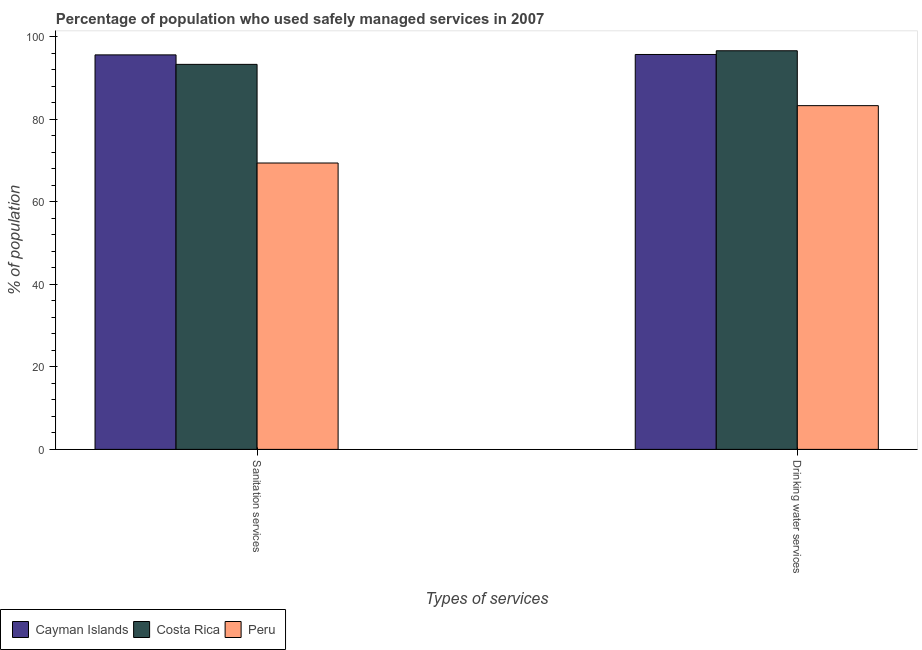Are the number of bars on each tick of the X-axis equal?
Provide a short and direct response. Yes. How many bars are there on the 2nd tick from the right?
Offer a very short reply. 3. What is the label of the 2nd group of bars from the left?
Offer a very short reply. Drinking water services. What is the percentage of population who used drinking water services in Costa Rica?
Provide a short and direct response. 96.6. Across all countries, what is the maximum percentage of population who used sanitation services?
Your response must be concise. 95.6. Across all countries, what is the minimum percentage of population who used sanitation services?
Offer a terse response. 69.4. In which country was the percentage of population who used sanitation services maximum?
Make the answer very short. Cayman Islands. In which country was the percentage of population who used drinking water services minimum?
Your answer should be very brief. Peru. What is the total percentage of population who used sanitation services in the graph?
Your answer should be very brief. 258.3. What is the difference between the percentage of population who used sanitation services in Costa Rica and that in Cayman Islands?
Provide a short and direct response. -2.3. What is the difference between the percentage of population who used drinking water services in Costa Rica and the percentage of population who used sanitation services in Cayman Islands?
Offer a very short reply. 1. What is the average percentage of population who used drinking water services per country?
Provide a short and direct response. 91.87. What is the difference between the percentage of population who used drinking water services and percentage of population who used sanitation services in Costa Rica?
Offer a very short reply. 3.3. In how many countries, is the percentage of population who used sanitation services greater than 76 %?
Make the answer very short. 2. What is the ratio of the percentage of population who used drinking water services in Cayman Islands to that in Costa Rica?
Offer a terse response. 0.99. What does the 3rd bar from the left in Drinking water services represents?
Offer a very short reply. Peru. How many bars are there?
Make the answer very short. 6. What is the difference between two consecutive major ticks on the Y-axis?
Give a very brief answer. 20. Where does the legend appear in the graph?
Offer a terse response. Bottom left. How are the legend labels stacked?
Provide a succinct answer. Horizontal. What is the title of the graph?
Give a very brief answer. Percentage of population who used safely managed services in 2007. Does "Croatia" appear as one of the legend labels in the graph?
Offer a terse response. No. What is the label or title of the X-axis?
Give a very brief answer. Types of services. What is the label or title of the Y-axis?
Ensure brevity in your answer.  % of population. What is the % of population of Cayman Islands in Sanitation services?
Ensure brevity in your answer.  95.6. What is the % of population of Costa Rica in Sanitation services?
Ensure brevity in your answer.  93.3. What is the % of population in Peru in Sanitation services?
Your answer should be very brief. 69.4. What is the % of population of Cayman Islands in Drinking water services?
Provide a short and direct response. 95.7. What is the % of population in Costa Rica in Drinking water services?
Offer a very short reply. 96.6. What is the % of population of Peru in Drinking water services?
Your answer should be very brief. 83.3. Across all Types of services, what is the maximum % of population of Cayman Islands?
Ensure brevity in your answer.  95.7. Across all Types of services, what is the maximum % of population of Costa Rica?
Your answer should be very brief. 96.6. Across all Types of services, what is the maximum % of population in Peru?
Make the answer very short. 83.3. Across all Types of services, what is the minimum % of population of Cayman Islands?
Offer a terse response. 95.6. Across all Types of services, what is the minimum % of population of Costa Rica?
Your answer should be compact. 93.3. Across all Types of services, what is the minimum % of population of Peru?
Your answer should be very brief. 69.4. What is the total % of population in Cayman Islands in the graph?
Make the answer very short. 191.3. What is the total % of population in Costa Rica in the graph?
Give a very brief answer. 189.9. What is the total % of population in Peru in the graph?
Your response must be concise. 152.7. What is the difference between the % of population of Costa Rica in Sanitation services and that in Drinking water services?
Provide a short and direct response. -3.3. What is the difference between the % of population in Cayman Islands in Sanitation services and the % of population in Costa Rica in Drinking water services?
Provide a short and direct response. -1. What is the difference between the % of population of Cayman Islands in Sanitation services and the % of population of Peru in Drinking water services?
Offer a very short reply. 12.3. What is the difference between the % of population in Costa Rica in Sanitation services and the % of population in Peru in Drinking water services?
Keep it short and to the point. 10. What is the average % of population in Cayman Islands per Types of services?
Provide a short and direct response. 95.65. What is the average % of population of Costa Rica per Types of services?
Ensure brevity in your answer.  94.95. What is the average % of population in Peru per Types of services?
Offer a very short reply. 76.35. What is the difference between the % of population of Cayman Islands and % of population of Costa Rica in Sanitation services?
Ensure brevity in your answer.  2.3. What is the difference between the % of population of Cayman Islands and % of population of Peru in Sanitation services?
Make the answer very short. 26.2. What is the difference between the % of population of Costa Rica and % of population of Peru in Sanitation services?
Provide a short and direct response. 23.9. What is the difference between the % of population of Cayman Islands and % of population of Peru in Drinking water services?
Your answer should be very brief. 12.4. What is the difference between the % of population of Costa Rica and % of population of Peru in Drinking water services?
Ensure brevity in your answer.  13.3. What is the ratio of the % of population in Costa Rica in Sanitation services to that in Drinking water services?
Keep it short and to the point. 0.97. What is the ratio of the % of population of Peru in Sanitation services to that in Drinking water services?
Offer a very short reply. 0.83. What is the difference between the highest and the second highest % of population in Cayman Islands?
Ensure brevity in your answer.  0.1. What is the difference between the highest and the second highest % of population in Costa Rica?
Provide a short and direct response. 3.3. What is the difference between the highest and the lowest % of population of Cayman Islands?
Offer a very short reply. 0.1. What is the difference between the highest and the lowest % of population of Costa Rica?
Make the answer very short. 3.3. 